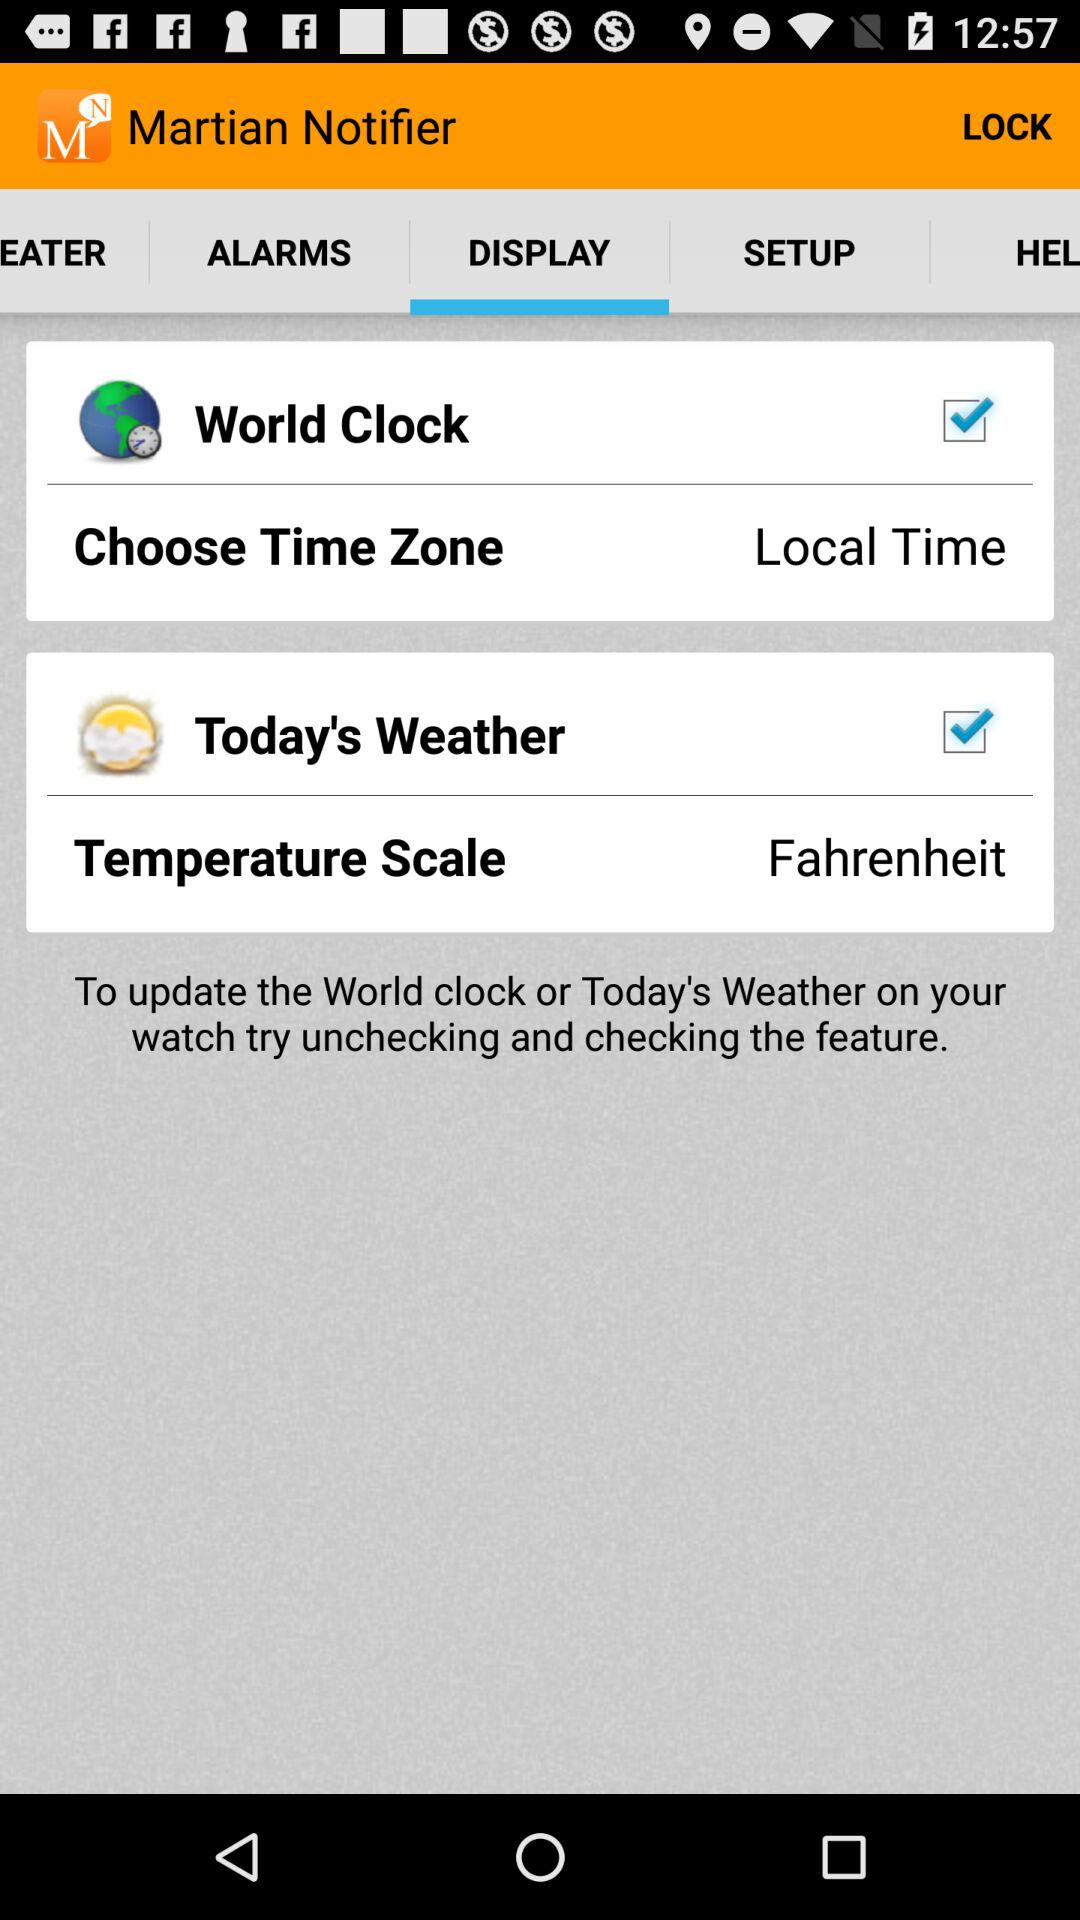Local time is chosen for which option? The option is "Choose Time Zone". 